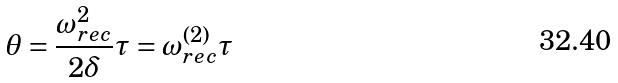Convert formula to latex. <formula><loc_0><loc_0><loc_500><loc_500>\theta = \frac { \omega _ { r e c } ^ { 2 } } { 2 \delta } \tau = \omega _ { r e c } ^ { ( 2 ) } \tau</formula> 